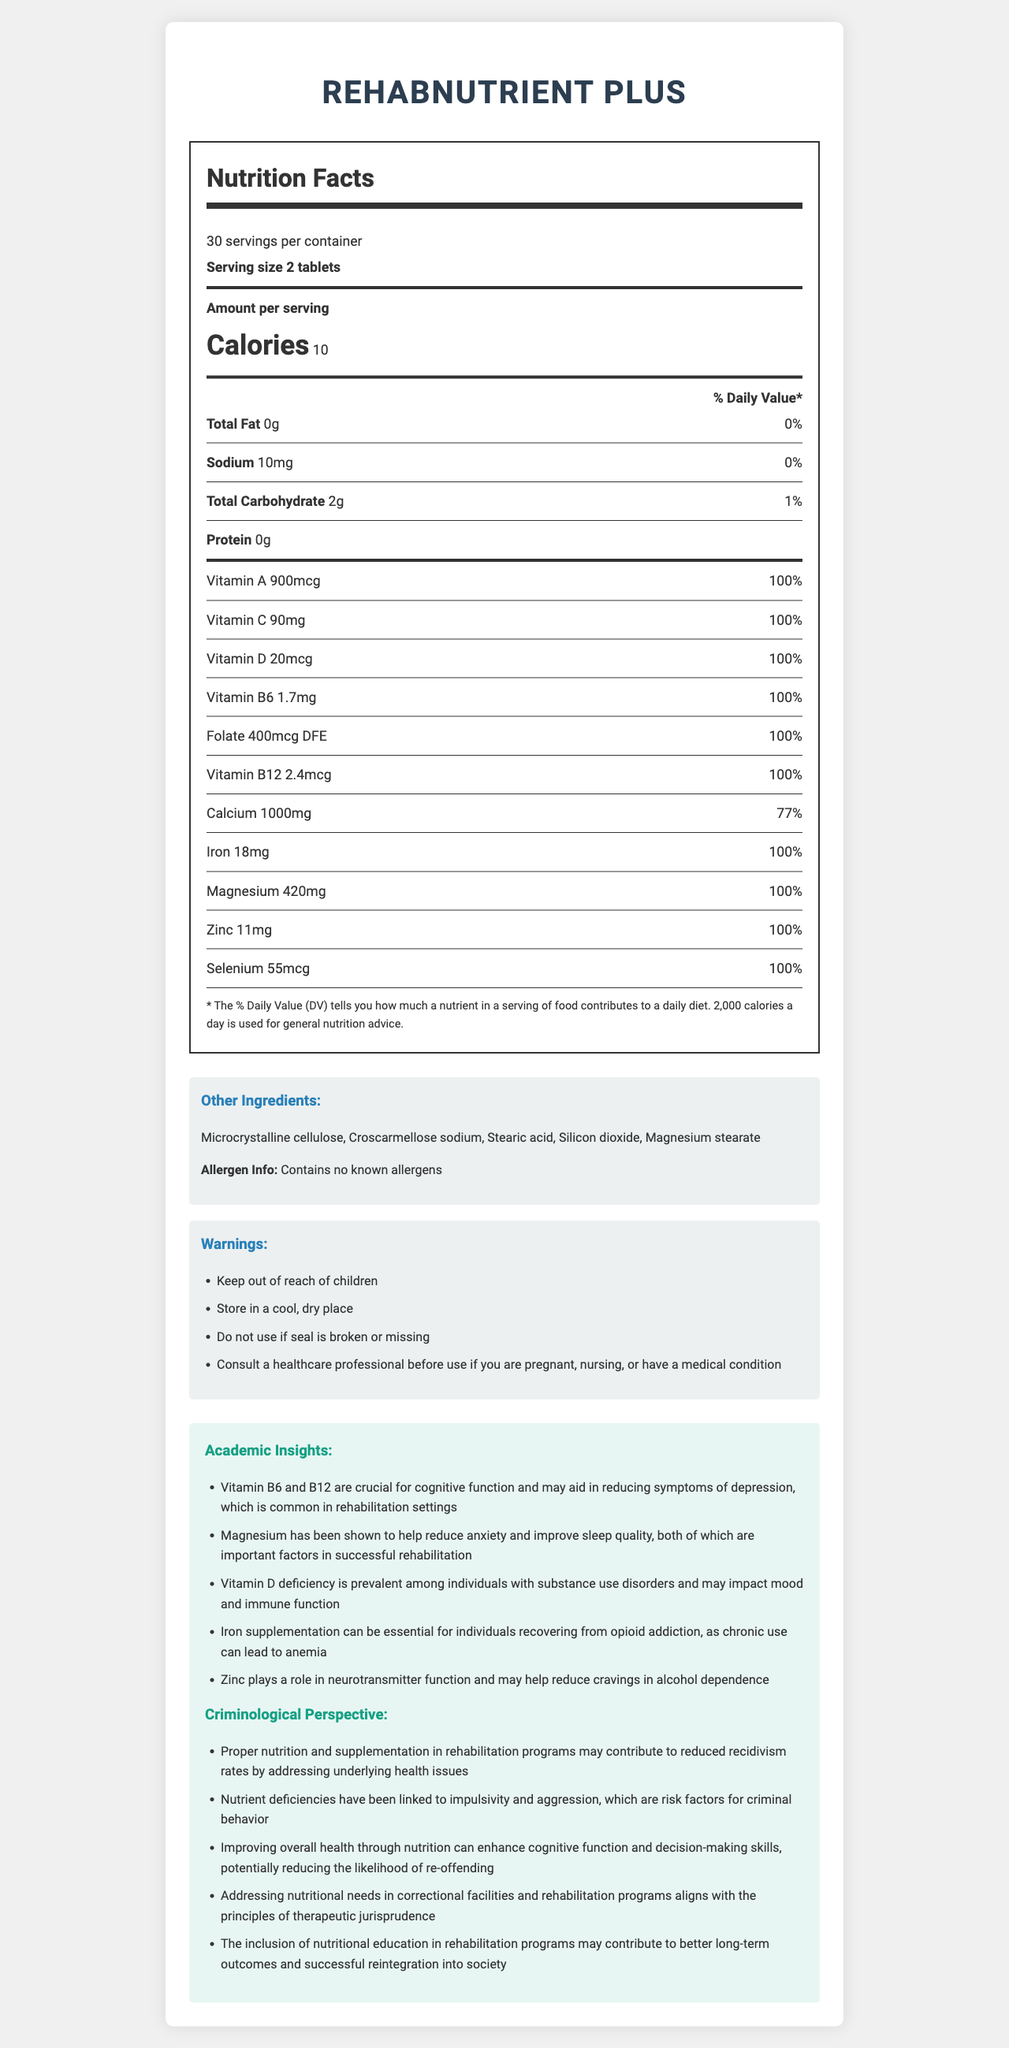what is the serving size for RehabNutrient Plus? The serving size is listed directly on the Nutrition Facts label as "2 tablets."
Answer: 2 tablets how many servings are in one container of RehabNutrient Plus? It is stated that there are "30 servings per container."
Answer: 30 what is the amount of Vitamin C per serving? The Nutrition Facts label lists Vitamin C as containing "90mg" per serving.
Answer: 90mg which vitamin has the highest daily value percentage listed? All these vitamins have a daily value of 100%, as mentioned in the Nutrition Facts label.
Answer: Vitamin A, Vitamin C, Vitamin D, Vitamin B6, Folate, Vitamin B12 how many milligrams of magnesium are present per serving? The Nutrition Facts label lists "Magnesium: 420mg."
Answer: 420mg what are the primary ingredients in RehabNutrient Plus? These are listed under "Other Ingredients" in the document.
Answer: Microcrystalline cellulose, Croscarmellose sodium, Stearic acid, Silicon dioxide, Magnesium stearate how is iron supplementation beneficial in rehabilitation settings? This insight is found under the "Academic Insights" section in the document.
Answer: It can help alleviate anemia caused by chronic opioid use. which mineral has the lowest daily value percentage? According to the Nutrition Facts label, Calcium has a daily value of 77%.
Answer: Calcium which of the following minerals is not included in RehabNutrient Plus? A. Magnesium B. Manganese C. Zinc D. Selenium Manganese is not listed among the minerals in the Nutrition Facts label.
Answer: B how does improving overall health through nutrition potentially impact recidivism rates? A. Increases addiction B. No impact C. Reduces recidivism rates D. Leads to more crimes Under the "Criminological Perspective" section, it states that proper nutrition may contribute to reduced recidivism rates by addressing underlying health issues.
Answer: C is this product known to contain any allergens? The document states, "Contains no known allergens."
Answer: No should children use RehabNutrient Plus without supervision? The warnings section advises to "Keep out of reach of children."
Answer: No what is the main idea of the document? This explanation summarizes the various sections and types of information included in the document.
Answer: The document provides detailed nutritional information about RehabNutrient Plus, including the breakdown of vitamins and minerals, other ingredients, and warnings. It also includes academic insights and criminological perspectives on how proper nutrition can support rehabilitation programs. what is the chemical composition of microcrystalline cellulose? The document lists microcrystalline cellulose as an ingredient but does not provide its chemical composition or detailed information about it.
Answer: Not enough information 